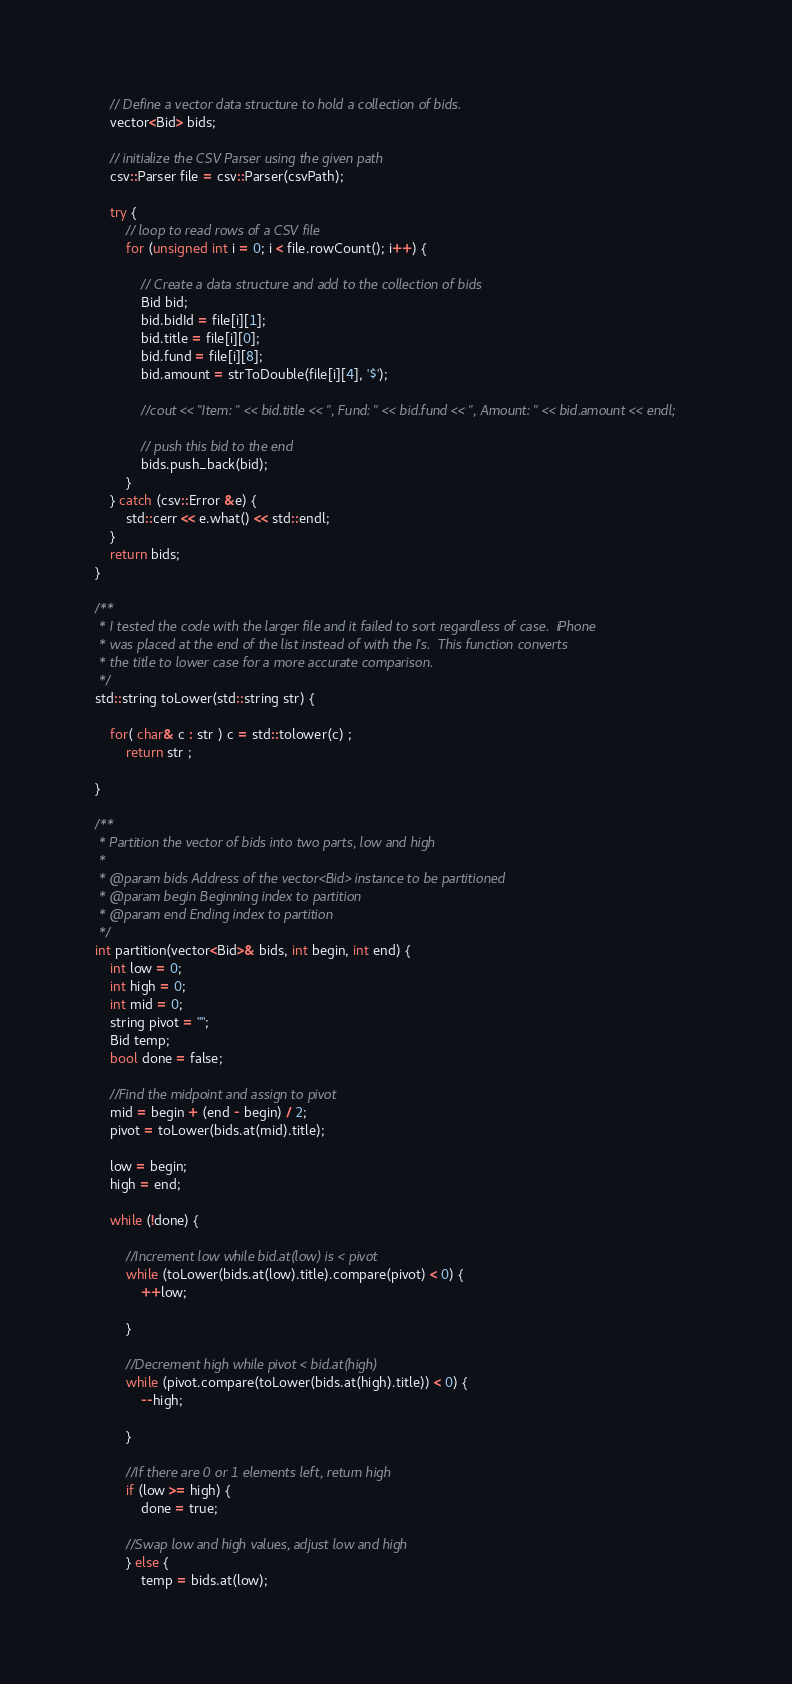<code> <loc_0><loc_0><loc_500><loc_500><_C++_>
    // Define a vector data structure to hold a collection of bids.
    vector<Bid> bids;

    // initialize the CSV Parser using the given path
    csv::Parser file = csv::Parser(csvPath);

    try {
        // loop to read rows of a CSV file
        for (unsigned int i = 0; i < file.rowCount(); i++) {

            // Create a data structure and add to the collection of bids
            Bid bid;
            bid.bidId = file[i][1];
            bid.title = file[i][0];
            bid.fund = file[i][8];
            bid.amount = strToDouble(file[i][4], '$');

            //cout << "Item: " << bid.title << ", Fund: " << bid.fund << ", Amount: " << bid.amount << endl;

            // push this bid to the end
            bids.push_back(bid);
        }
    } catch (csv::Error &e) {
        std::cerr << e.what() << std::endl;
    }
    return bids;
}

/**
 * I tested the code with the larger file and it failed to sort regardless of case.  iPhone
 * was placed at the end of the list instead of with the I's.  This function converts
 * the title to lower case for a more accurate comparison.
 */
std::string toLower(std::string str) {

	for( char& c : str ) c = std::tolower(c) ;
		return str ;

}

/**
 * Partition the vector of bids into two parts, low and high
 *
 * @param bids Address of the vector<Bid> instance to be partitioned
 * @param begin Beginning index to partition
 * @param end Ending index to partition
 */
int partition(vector<Bid>& bids, int begin, int end) {
	int low = 0;
	int high = 0;
	int mid = 0;
	string pivot = "";
	Bid temp;
	bool done = false;

	//Find the midpoint and assign to pivot
	mid = begin + (end - begin) / 2;
	pivot = toLower(bids.at(mid).title);

	low = begin;
	high = end;

	while (!done) {

		//Increment low while bid.at(low) is < pivot
		while (toLower(bids.at(low).title).compare(pivot) < 0) {
			++low;

		}

		//Decrement high while pivot < bid.at(high)
		while (pivot.compare(toLower(bids.at(high).title)) < 0) {
			--high;

		}

		//If there are 0 or 1 elements left, return high
		if (low >= high) {
			done = true;

		//Swap low and high values, adjust low and high
		} else {
			temp = bids.at(low);</code> 